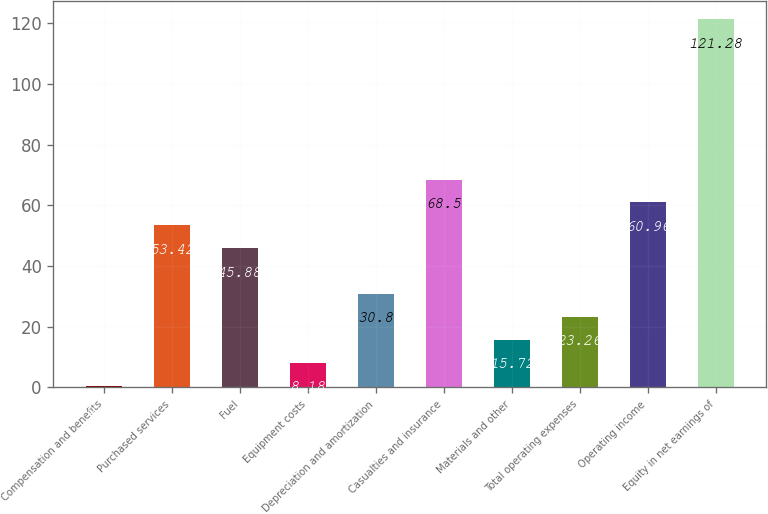Convert chart. <chart><loc_0><loc_0><loc_500><loc_500><bar_chart><fcel>Compensation and benefits<fcel>Purchased services<fcel>Fuel<fcel>Equipment costs<fcel>Depreciation and amortization<fcel>Casualties and insurance<fcel>Materials and other<fcel>Total operating expenses<fcel>Operating income<fcel>Equity in net earnings of<nl><fcel>0.64<fcel>53.42<fcel>45.88<fcel>8.18<fcel>30.8<fcel>68.5<fcel>15.72<fcel>23.26<fcel>60.96<fcel>121.28<nl></chart> 